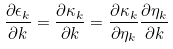<formula> <loc_0><loc_0><loc_500><loc_500>\frac { \partial \epsilon _ { k } } { \partial k } = \frac { \partial \kappa _ { k } } { \partial k } = \frac { \partial \kappa _ { k } } { \partial \eta _ { k } } \frac { \partial \eta _ { k } } { \partial k }</formula> 